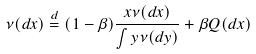Convert formula to latex. <formula><loc_0><loc_0><loc_500><loc_500>\nu ( d x ) \stackrel { d } { = } ( 1 - \beta ) \frac { x \nu ( d x ) } { \int y \nu ( d y ) } + \beta Q ( d x )</formula> 